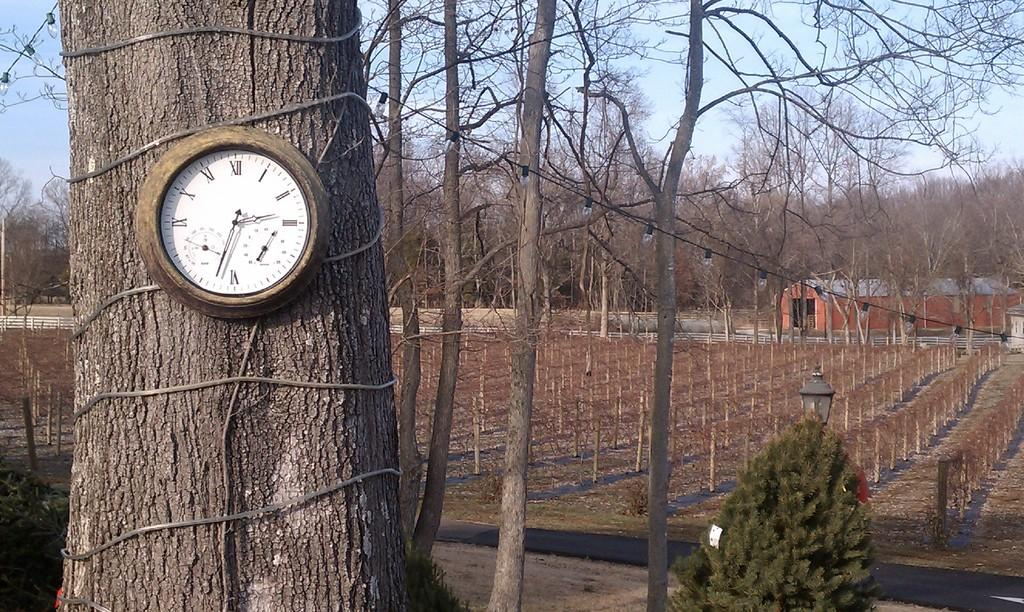<image>
Present a compact description of the photo's key features. An analog wall clock mounted on a tree trunk outdoors with Roman Numerals. 